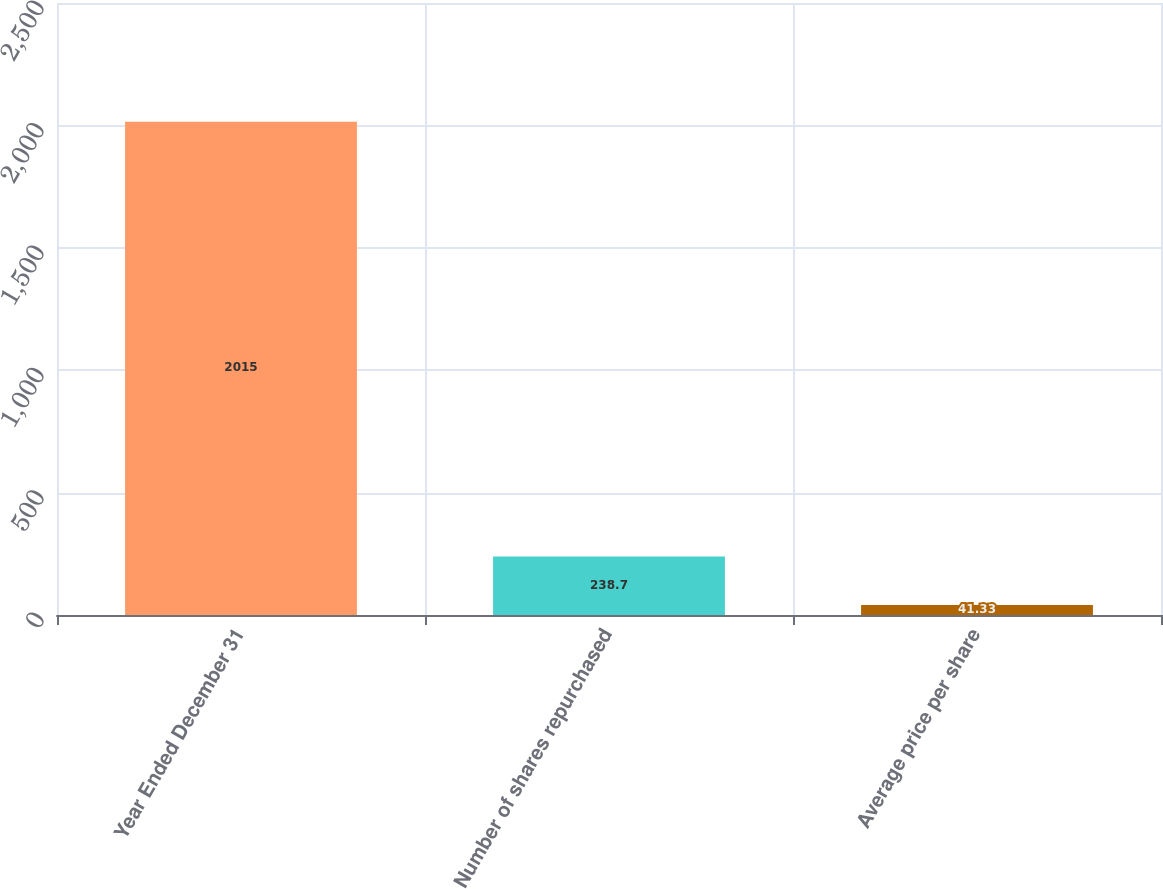Convert chart to OTSL. <chart><loc_0><loc_0><loc_500><loc_500><bar_chart><fcel>Year Ended December 31<fcel>Number of shares repurchased<fcel>Average price per share<nl><fcel>2015<fcel>238.7<fcel>41.33<nl></chart> 